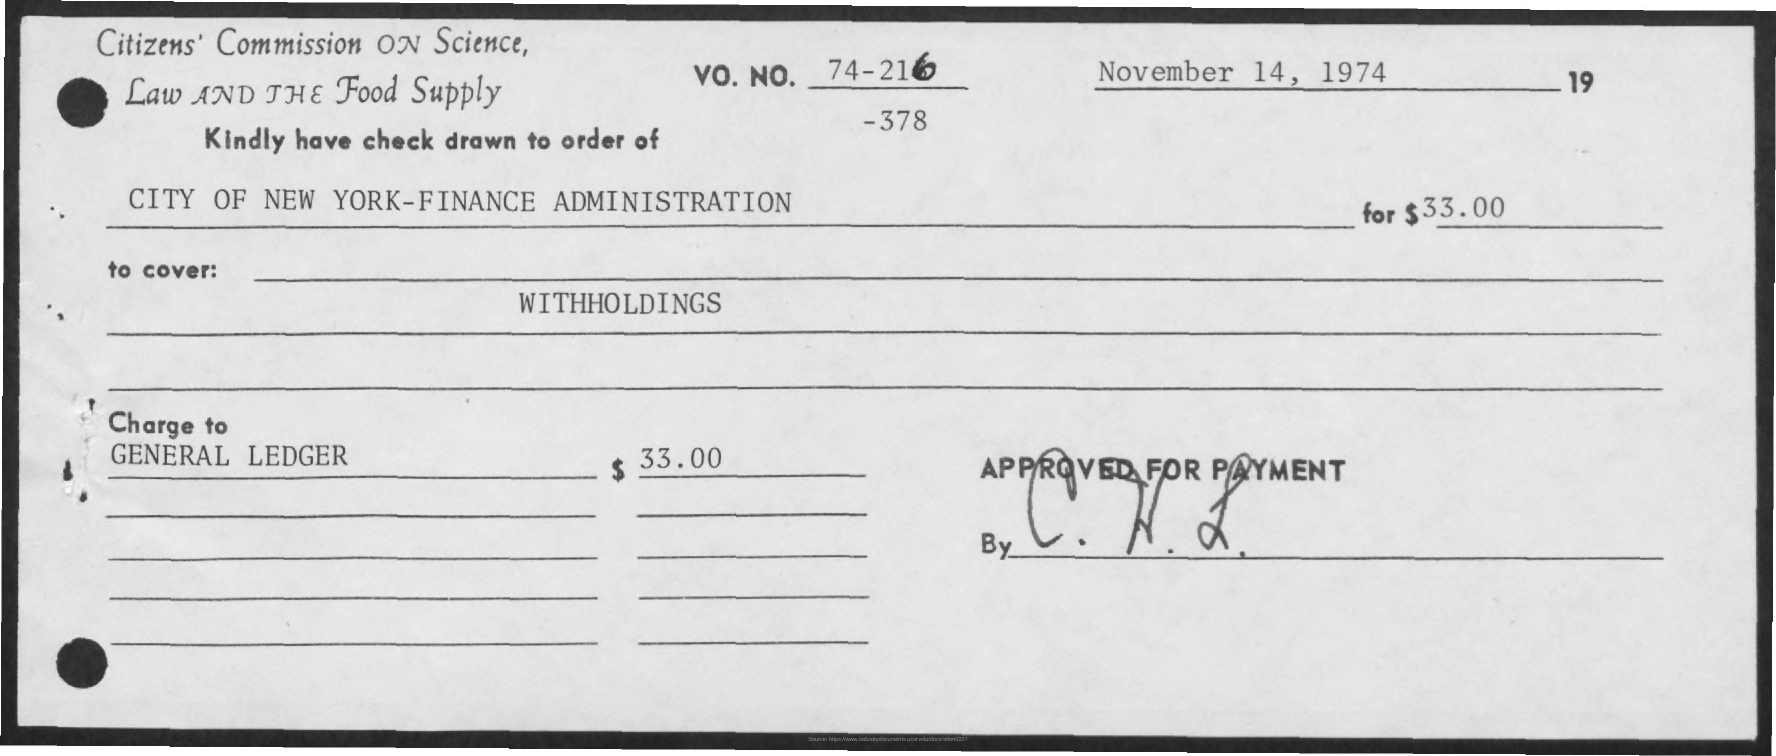Who is the cheque drawn to, and what's its value? The cheque is drawn to the order of 'CITY OF NEW YORK-FINANCE ADMINISTRATION' and the value written on the cheque is $33.00. Could you give more details about the item 'WITHHOLDINGS' mentioned on the cheque? The term 'WITHHOLDINGS' generally refers to amounts of money that are held back or retained, such as taxes or other deductions from income. In this context, it suggests that the cheque is to settle such withheld funds, though for specific detail one would need additional documentation or context. 